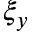Convert formula to latex. <formula><loc_0><loc_0><loc_500><loc_500>\xi _ { y }</formula> 